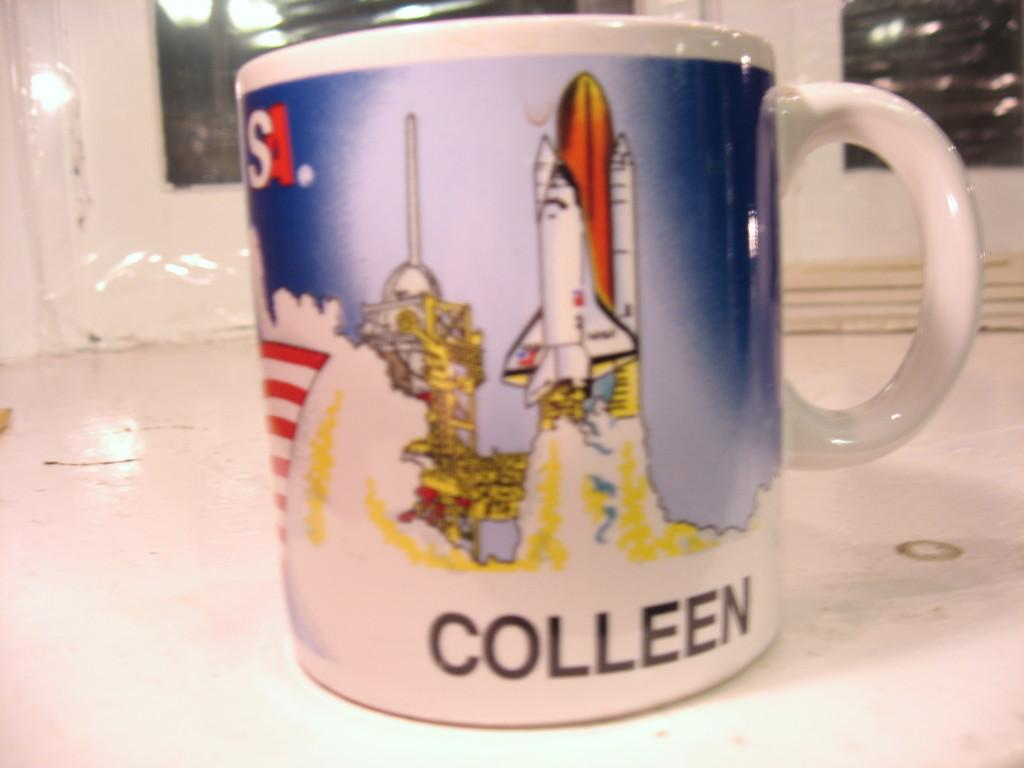<image>
Offer a succinct explanation of the picture presented. A coffee cup with a rocket ship and the name Colleen sits on a white floor. 